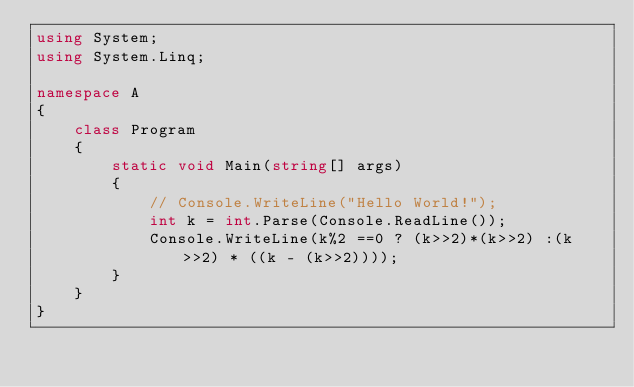Convert code to text. <code><loc_0><loc_0><loc_500><loc_500><_C#_>using System;
using System.Linq;

namespace A
{
    class Program
    {
        static void Main(string[] args)
        {
            // Console.WriteLine("Hello World!");
            int k = int.Parse(Console.ReadLine());
            Console.WriteLine(k%2 ==0 ? (k>>2)*(k>>2) :(k>>2) * ((k - (k>>2))));
        }
    }
}
</code> 